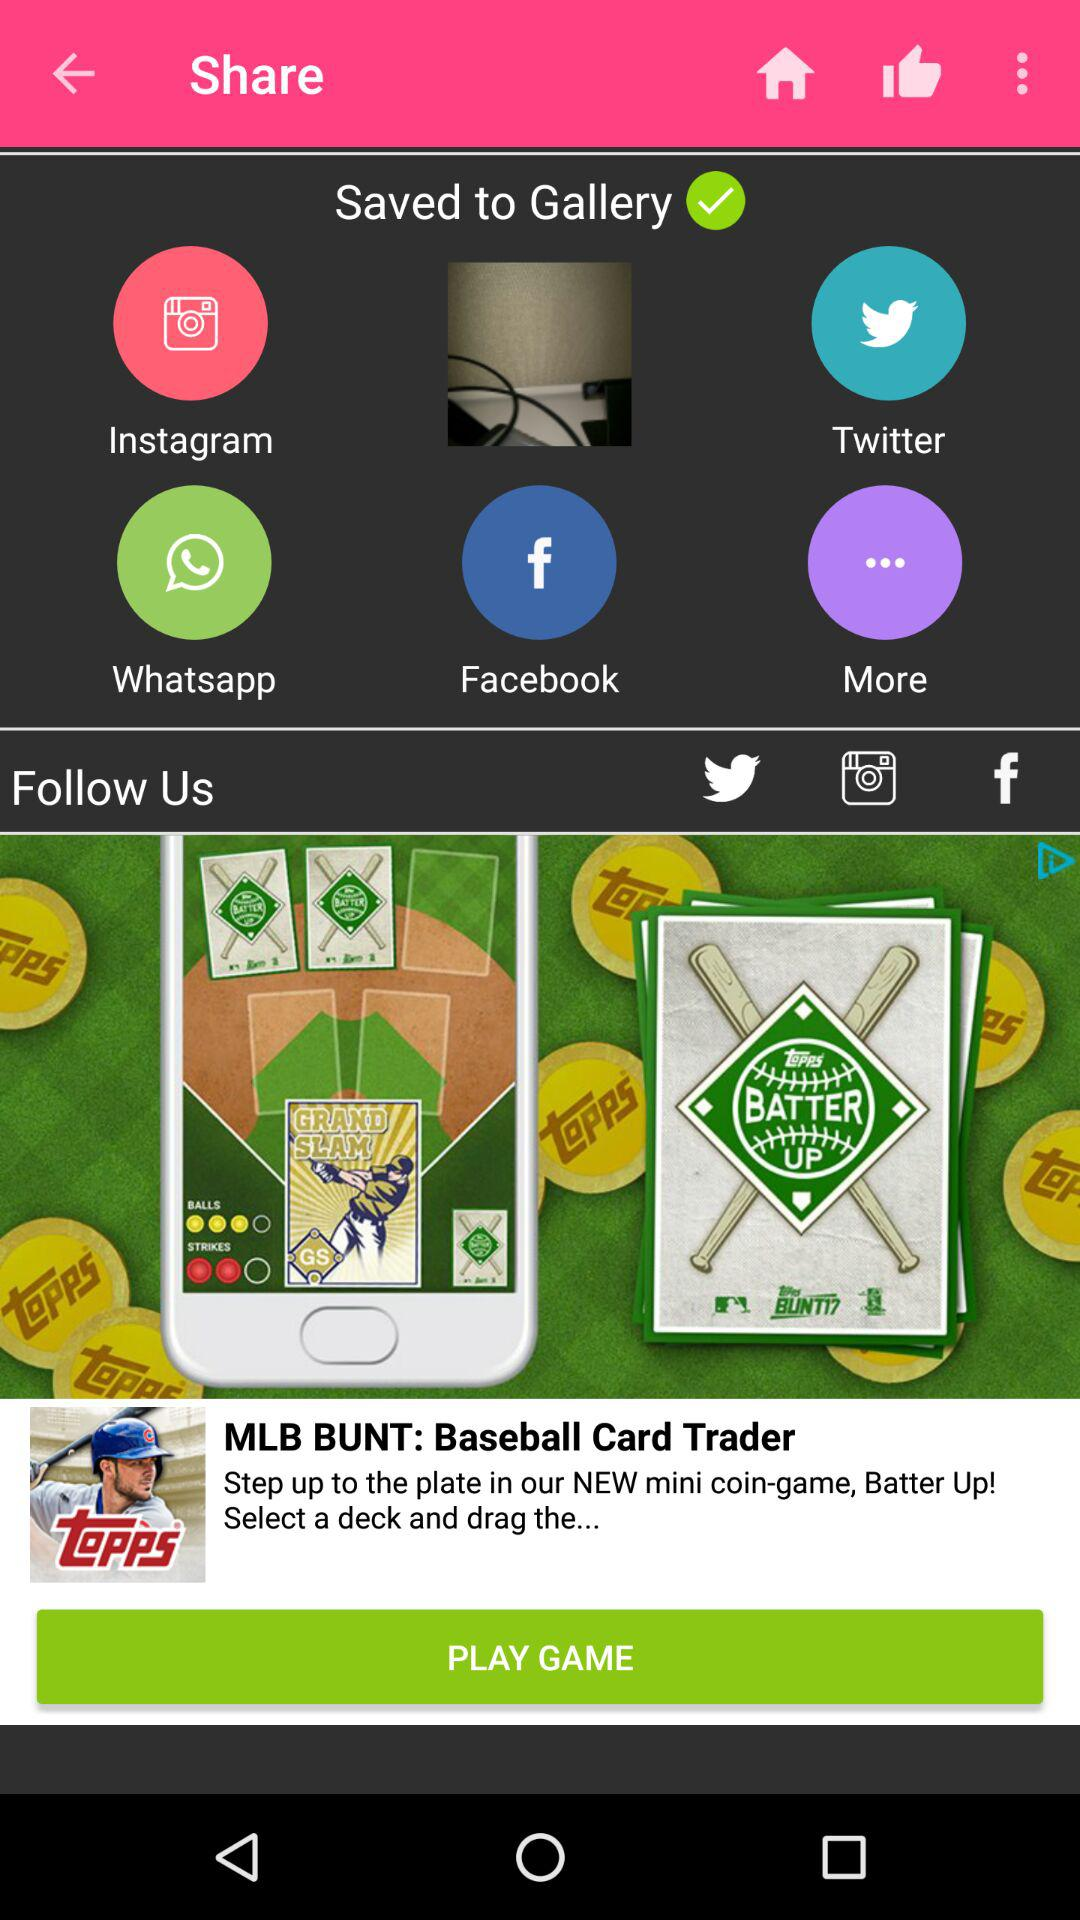Which galleries are we able to save in?
When the provided information is insufficient, respond with <no answer>. <no answer> 